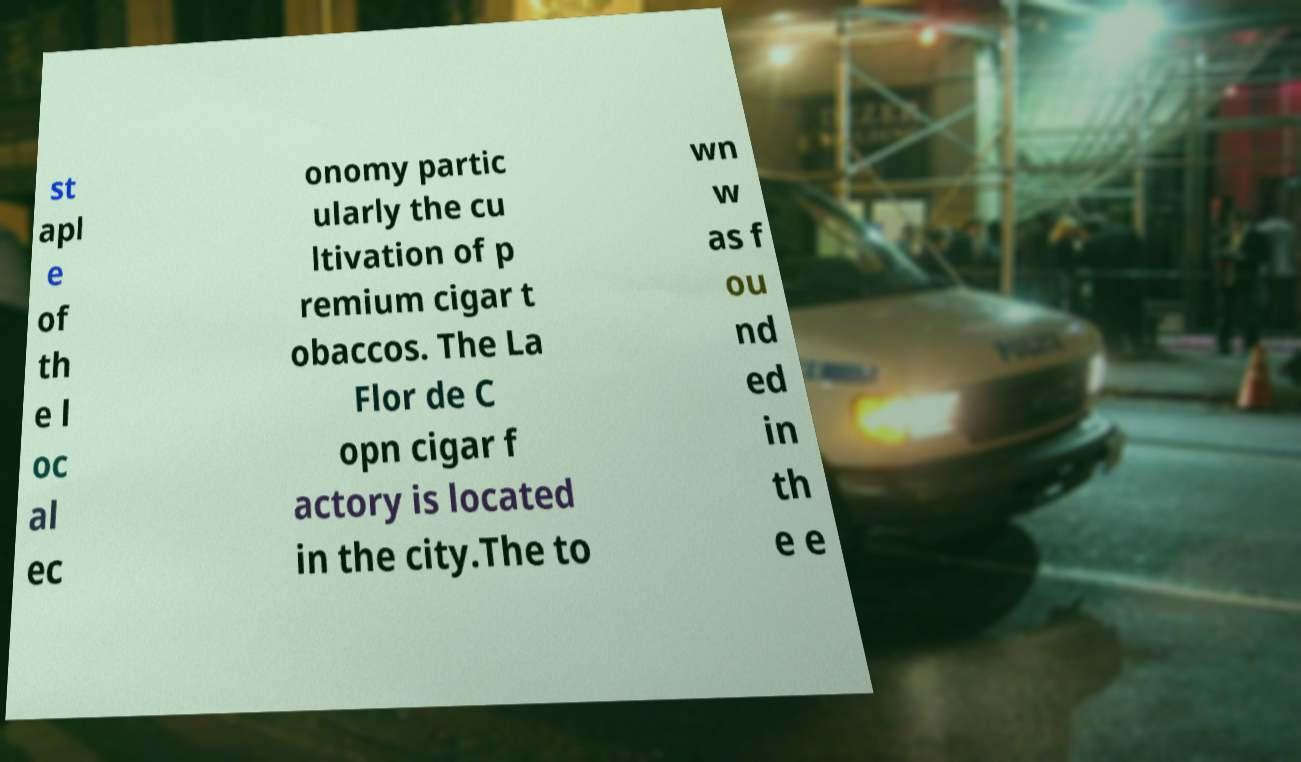Could you extract and type out the text from this image? st apl e of th e l oc al ec onomy partic ularly the cu ltivation of p remium cigar t obaccos. The La Flor de C opn cigar f actory is located in the city.The to wn w as f ou nd ed in th e e 